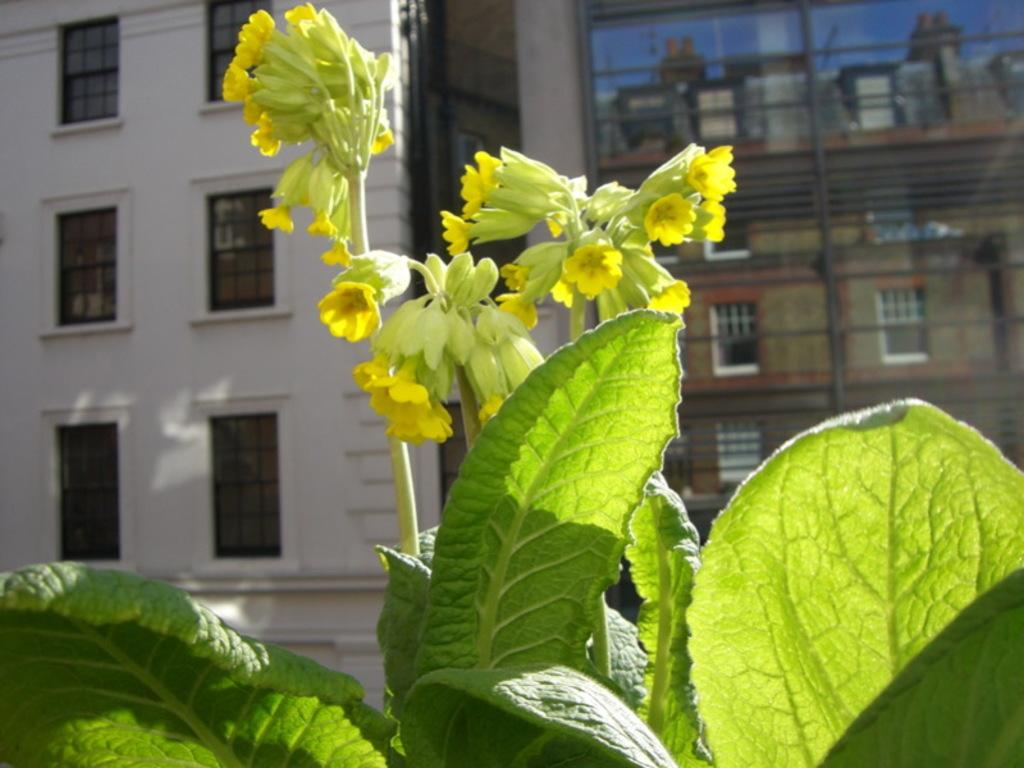What type of plant is visible in the image? There is a plant with flowers in the image. What can be seen in the background of the image? There are buildings with windows in the background of the image. What type of history lesson is being taught in the image? There is no indication of a history lesson or any learning activity in the image. 